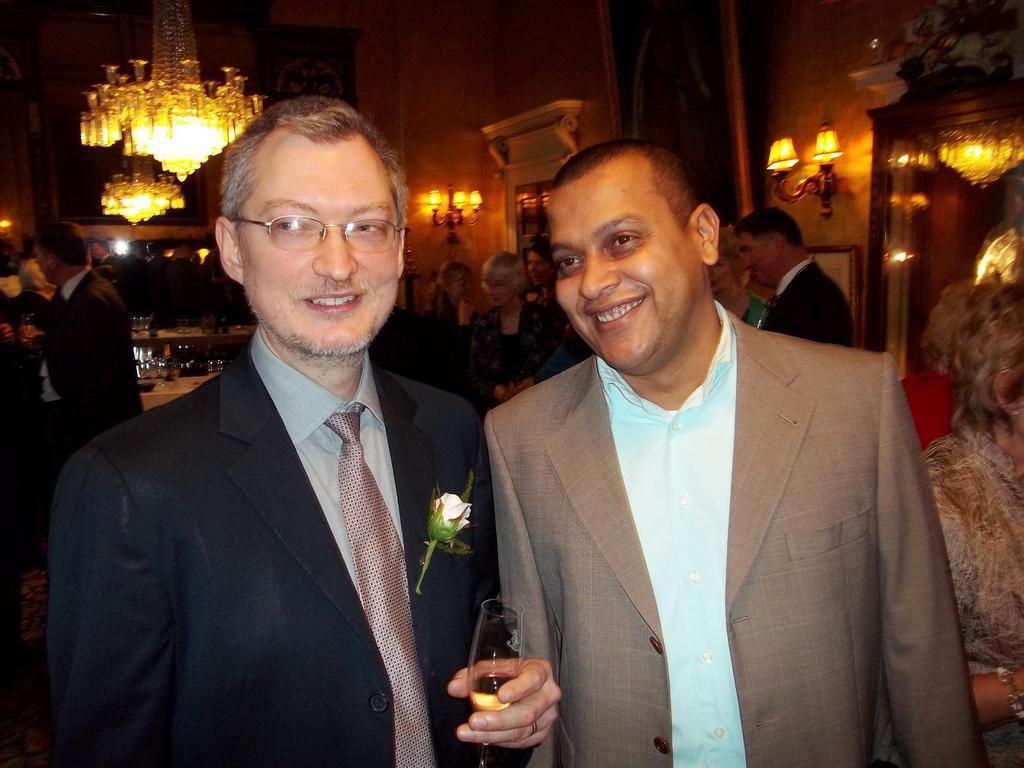Could you give a brief overview of what you see in this image? In this image, I can see two persons standing and smiling. At the top of the image, I can see two chandeliers. In the background, there are groups of people, lamps and photo frames attached to the wall. On the right side of the image, I can see a mirror. 